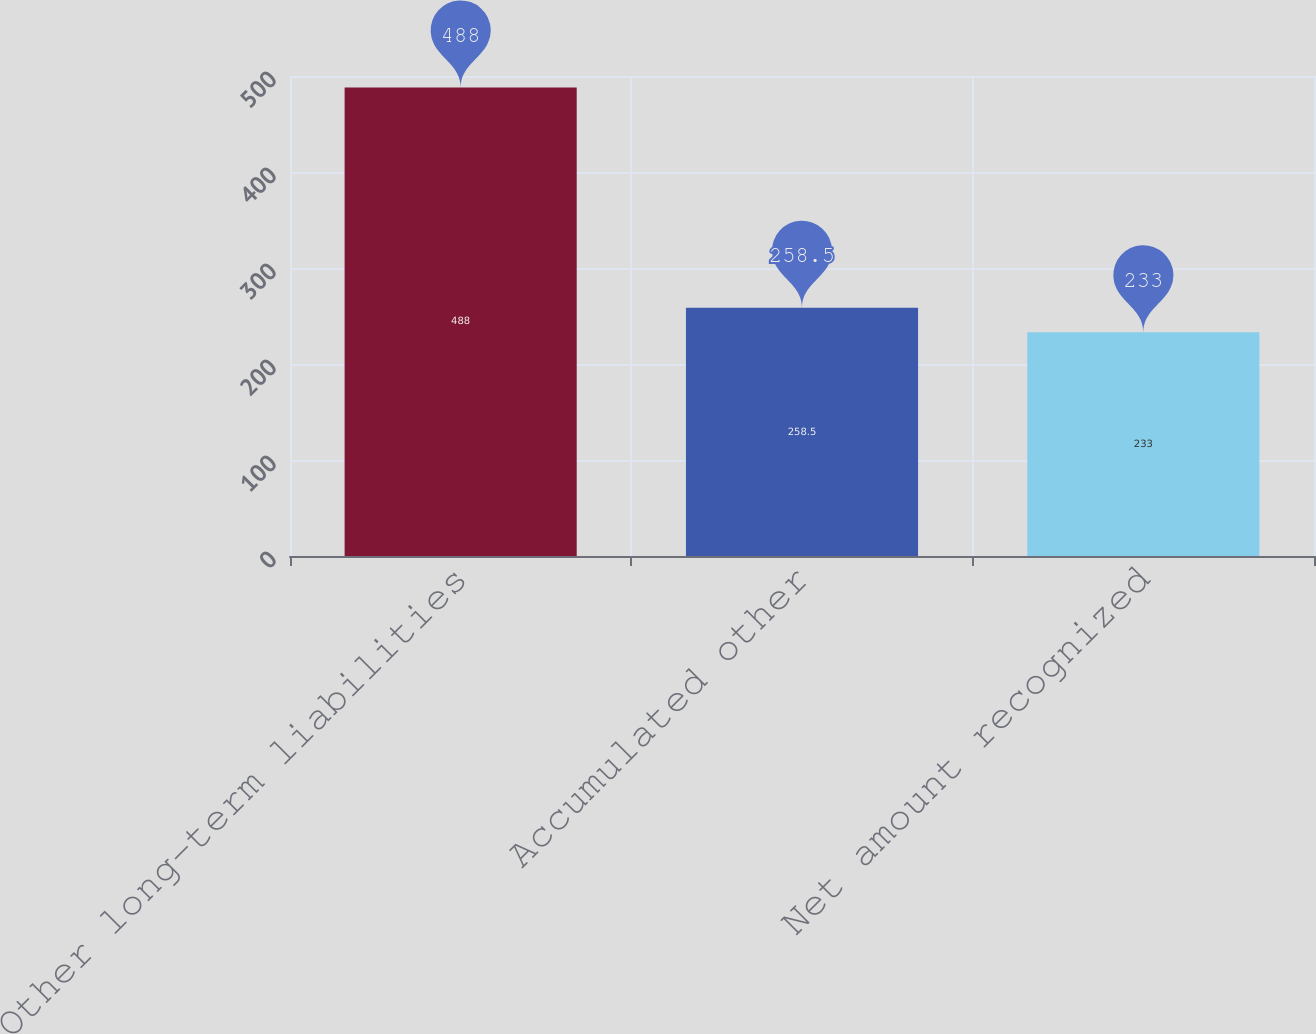<chart> <loc_0><loc_0><loc_500><loc_500><bar_chart><fcel>Other long-term liabilities<fcel>Accumulated other<fcel>Net amount recognized<nl><fcel>488<fcel>258.5<fcel>233<nl></chart> 